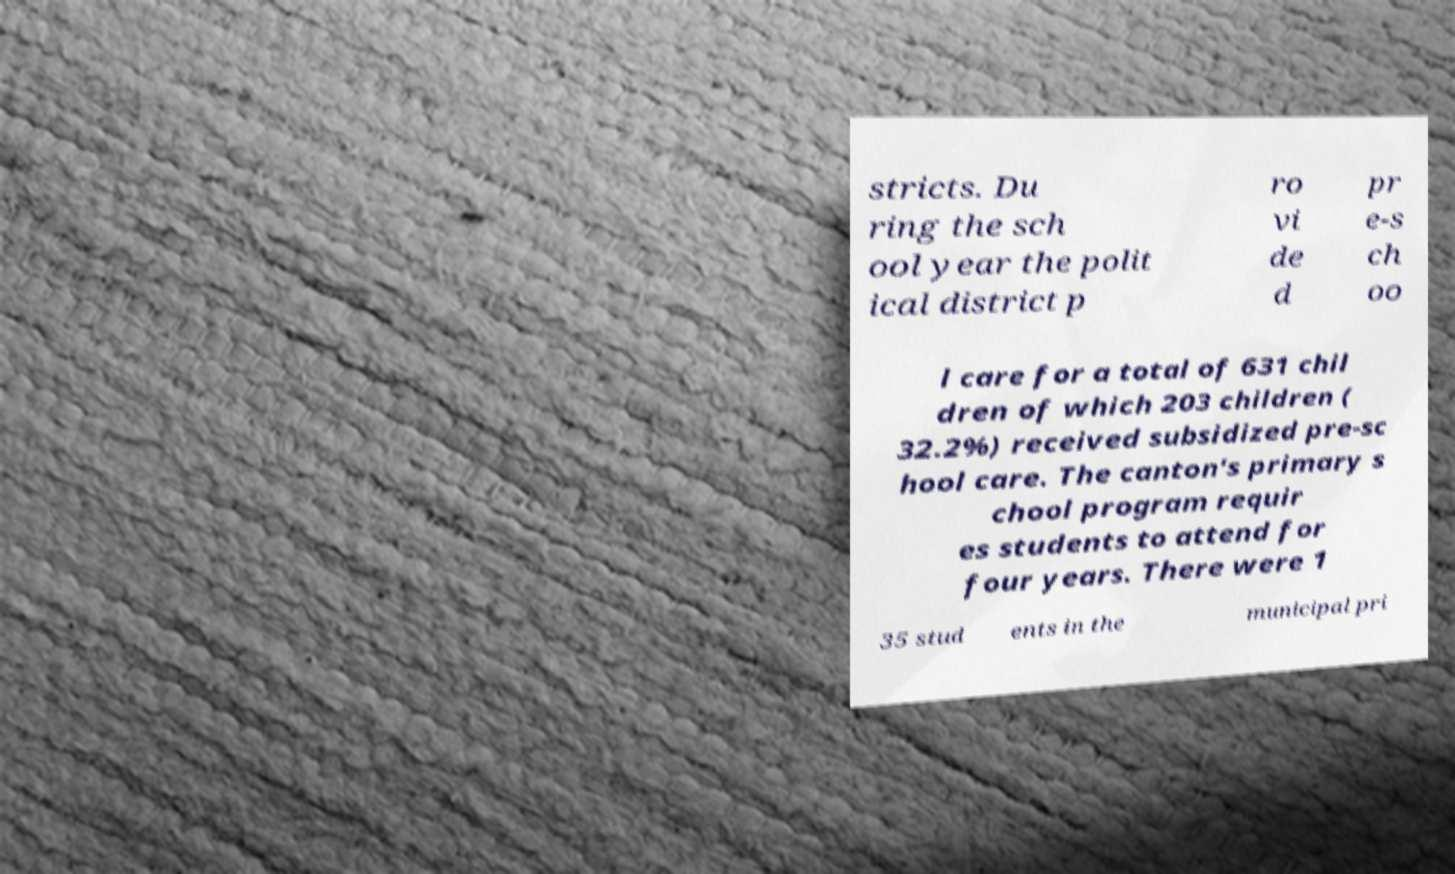Could you extract and type out the text from this image? stricts. Du ring the sch ool year the polit ical district p ro vi de d pr e-s ch oo l care for a total of 631 chil dren of which 203 children ( 32.2%) received subsidized pre-sc hool care. The canton's primary s chool program requir es students to attend for four years. There were 1 35 stud ents in the municipal pri 